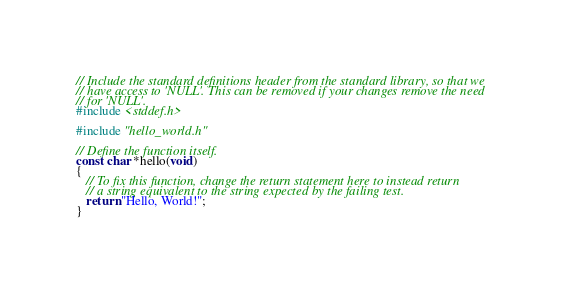Convert code to text. <code><loc_0><loc_0><loc_500><loc_500><_C_>// Include the standard definitions header from the standard library, so that we
// have access to 'NULL'. This can be removed if your changes remove the need
// for 'NULL'.
#include <stddef.h>

#include "hello_world.h"

// Define the function itself.
const char *hello(void)
{
   // To fix this function, change the return statement here to instead return
   // a string equivalent to the string expected by the failing test.
   return "Hello, World!";
}
</code> 